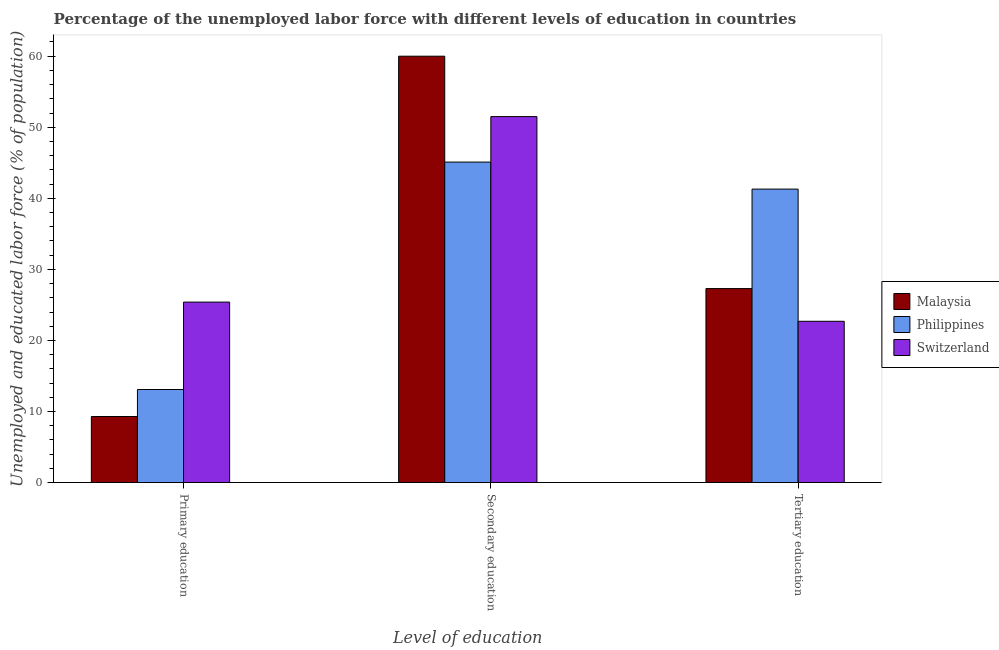How many different coloured bars are there?
Your answer should be very brief. 3. Are the number of bars on each tick of the X-axis equal?
Provide a short and direct response. Yes. How many bars are there on the 2nd tick from the left?
Offer a terse response. 3. What is the label of the 2nd group of bars from the left?
Provide a short and direct response. Secondary education. What is the percentage of labor force who received secondary education in Philippines?
Give a very brief answer. 45.1. Across all countries, what is the minimum percentage of labor force who received secondary education?
Keep it short and to the point. 45.1. In which country was the percentage of labor force who received primary education maximum?
Your response must be concise. Switzerland. In which country was the percentage of labor force who received tertiary education minimum?
Provide a short and direct response. Switzerland. What is the total percentage of labor force who received tertiary education in the graph?
Provide a succinct answer. 91.3. What is the difference between the percentage of labor force who received primary education in Malaysia and that in Switzerland?
Keep it short and to the point. -16.1. What is the difference between the percentage of labor force who received secondary education in Philippines and the percentage of labor force who received primary education in Malaysia?
Provide a short and direct response. 35.8. What is the average percentage of labor force who received tertiary education per country?
Keep it short and to the point. 30.43. What is the difference between the percentage of labor force who received tertiary education and percentage of labor force who received secondary education in Philippines?
Your answer should be compact. -3.8. In how many countries, is the percentage of labor force who received primary education greater than 32 %?
Ensure brevity in your answer.  0. What is the ratio of the percentage of labor force who received tertiary education in Malaysia to that in Switzerland?
Provide a succinct answer. 1.2. Is the difference between the percentage of labor force who received tertiary education in Malaysia and Switzerland greater than the difference between the percentage of labor force who received secondary education in Malaysia and Switzerland?
Give a very brief answer. No. What is the difference between the highest and the lowest percentage of labor force who received secondary education?
Your answer should be very brief. 14.9. In how many countries, is the percentage of labor force who received secondary education greater than the average percentage of labor force who received secondary education taken over all countries?
Provide a short and direct response. 1. Is the sum of the percentage of labor force who received tertiary education in Philippines and Switzerland greater than the maximum percentage of labor force who received primary education across all countries?
Provide a short and direct response. Yes. What does the 1st bar from the right in Primary education represents?
Your response must be concise. Switzerland. Is it the case that in every country, the sum of the percentage of labor force who received primary education and percentage of labor force who received secondary education is greater than the percentage of labor force who received tertiary education?
Ensure brevity in your answer.  Yes. Are all the bars in the graph horizontal?
Ensure brevity in your answer.  No. How many countries are there in the graph?
Your answer should be very brief. 3. What is the difference between two consecutive major ticks on the Y-axis?
Your response must be concise. 10. Does the graph contain any zero values?
Provide a short and direct response. No. Does the graph contain grids?
Your answer should be very brief. No. How many legend labels are there?
Provide a short and direct response. 3. What is the title of the graph?
Make the answer very short. Percentage of the unemployed labor force with different levels of education in countries. Does "Israel" appear as one of the legend labels in the graph?
Provide a short and direct response. No. What is the label or title of the X-axis?
Your answer should be very brief. Level of education. What is the label or title of the Y-axis?
Make the answer very short. Unemployed and educated labor force (% of population). What is the Unemployed and educated labor force (% of population) in Malaysia in Primary education?
Make the answer very short. 9.3. What is the Unemployed and educated labor force (% of population) in Philippines in Primary education?
Keep it short and to the point. 13.1. What is the Unemployed and educated labor force (% of population) of Switzerland in Primary education?
Provide a succinct answer. 25.4. What is the Unemployed and educated labor force (% of population) in Philippines in Secondary education?
Your answer should be compact. 45.1. What is the Unemployed and educated labor force (% of population) of Switzerland in Secondary education?
Make the answer very short. 51.5. What is the Unemployed and educated labor force (% of population) in Malaysia in Tertiary education?
Make the answer very short. 27.3. What is the Unemployed and educated labor force (% of population) in Philippines in Tertiary education?
Give a very brief answer. 41.3. What is the Unemployed and educated labor force (% of population) in Switzerland in Tertiary education?
Ensure brevity in your answer.  22.7. Across all Level of education, what is the maximum Unemployed and educated labor force (% of population) of Malaysia?
Offer a very short reply. 60. Across all Level of education, what is the maximum Unemployed and educated labor force (% of population) in Philippines?
Your answer should be very brief. 45.1. Across all Level of education, what is the maximum Unemployed and educated labor force (% of population) in Switzerland?
Give a very brief answer. 51.5. Across all Level of education, what is the minimum Unemployed and educated labor force (% of population) of Malaysia?
Make the answer very short. 9.3. Across all Level of education, what is the minimum Unemployed and educated labor force (% of population) of Philippines?
Provide a succinct answer. 13.1. Across all Level of education, what is the minimum Unemployed and educated labor force (% of population) in Switzerland?
Offer a very short reply. 22.7. What is the total Unemployed and educated labor force (% of population) of Malaysia in the graph?
Your answer should be very brief. 96.6. What is the total Unemployed and educated labor force (% of population) in Philippines in the graph?
Your answer should be compact. 99.5. What is the total Unemployed and educated labor force (% of population) in Switzerland in the graph?
Keep it short and to the point. 99.6. What is the difference between the Unemployed and educated labor force (% of population) in Malaysia in Primary education and that in Secondary education?
Provide a succinct answer. -50.7. What is the difference between the Unemployed and educated labor force (% of population) in Philippines in Primary education and that in Secondary education?
Your response must be concise. -32. What is the difference between the Unemployed and educated labor force (% of population) in Switzerland in Primary education and that in Secondary education?
Offer a very short reply. -26.1. What is the difference between the Unemployed and educated labor force (% of population) in Philippines in Primary education and that in Tertiary education?
Provide a short and direct response. -28.2. What is the difference between the Unemployed and educated labor force (% of population) of Switzerland in Primary education and that in Tertiary education?
Your answer should be very brief. 2.7. What is the difference between the Unemployed and educated labor force (% of population) in Malaysia in Secondary education and that in Tertiary education?
Keep it short and to the point. 32.7. What is the difference between the Unemployed and educated labor force (% of population) of Switzerland in Secondary education and that in Tertiary education?
Your response must be concise. 28.8. What is the difference between the Unemployed and educated labor force (% of population) in Malaysia in Primary education and the Unemployed and educated labor force (% of population) in Philippines in Secondary education?
Your answer should be compact. -35.8. What is the difference between the Unemployed and educated labor force (% of population) of Malaysia in Primary education and the Unemployed and educated labor force (% of population) of Switzerland in Secondary education?
Your response must be concise. -42.2. What is the difference between the Unemployed and educated labor force (% of population) in Philippines in Primary education and the Unemployed and educated labor force (% of population) in Switzerland in Secondary education?
Your answer should be compact. -38.4. What is the difference between the Unemployed and educated labor force (% of population) of Malaysia in Primary education and the Unemployed and educated labor force (% of population) of Philippines in Tertiary education?
Make the answer very short. -32. What is the difference between the Unemployed and educated labor force (% of population) of Malaysia in Primary education and the Unemployed and educated labor force (% of population) of Switzerland in Tertiary education?
Keep it short and to the point. -13.4. What is the difference between the Unemployed and educated labor force (% of population) in Malaysia in Secondary education and the Unemployed and educated labor force (% of population) in Switzerland in Tertiary education?
Give a very brief answer. 37.3. What is the difference between the Unemployed and educated labor force (% of population) in Philippines in Secondary education and the Unemployed and educated labor force (% of population) in Switzerland in Tertiary education?
Your answer should be very brief. 22.4. What is the average Unemployed and educated labor force (% of population) in Malaysia per Level of education?
Your answer should be very brief. 32.2. What is the average Unemployed and educated labor force (% of population) of Philippines per Level of education?
Keep it short and to the point. 33.17. What is the average Unemployed and educated labor force (% of population) of Switzerland per Level of education?
Give a very brief answer. 33.2. What is the difference between the Unemployed and educated labor force (% of population) in Malaysia and Unemployed and educated labor force (% of population) in Switzerland in Primary education?
Your response must be concise. -16.1. What is the difference between the Unemployed and educated labor force (% of population) of Malaysia and Unemployed and educated labor force (% of population) of Philippines in Secondary education?
Provide a succinct answer. 14.9. What is the difference between the Unemployed and educated labor force (% of population) of Malaysia and Unemployed and educated labor force (% of population) of Switzerland in Secondary education?
Your answer should be compact. 8.5. What is the difference between the Unemployed and educated labor force (% of population) of Philippines and Unemployed and educated labor force (% of population) of Switzerland in Secondary education?
Keep it short and to the point. -6.4. What is the difference between the Unemployed and educated labor force (% of population) in Malaysia and Unemployed and educated labor force (% of population) in Switzerland in Tertiary education?
Provide a succinct answer. 4.6. What is the ratio of the Unemployed and educated labor force (% of population) in Malaysia in Primary education to that in Secondary education?
Offer a very short reply. 0.15. What is the ratio of the Unemployed and educated labor force (% of population) in Philippines in Primary education to that in Secondary education?
Your answer should be very brief. 0.29. What is the ratio of the Unemployed and educated labor force (% of population) in Switzerland in Primary education to that in Secondary education?
Your answer should be compact. 0.49. What is the ratio of the Unemployed and educated labor force (% of population) in Malaysia in Primary education to that in Tertiary education?
Give a very brief answer. 0.34. What is the ratio of the Unemployed and educated labor force (% of population) in Philippines in Primary education to that in Tertiary education?
Your answer should be very brief. 0.32. What is the ratio of the Unemployed and educated labor force (% of population) of Switzerland in Primary education to that in Tertiary education?
Offer a very short reply. 1.12. What is the ratio of the Unemployed and educated labor force (% of population) of Malaysia in Secondary education to that in Tertiary education?
Your answer should be very brief. 2.2. What is the ratio of the Unemployed and educated labor force (% of population) in Philippines in Secondary education to that in Tertiary education?
Make the answer very short. 1.09. What is the ratio of the Unemployed and educated labor force (% of population) of Switzerland in Secondary education to that in Tertiary education?
Offer a terse response. 2.27. What is the difference between the highest and the second highest Unemployed and educated labor force (% of population) of Malaysia?
Offer a terse response. 32.7. What is the difference between the highest and the second highest Unemployed and educated labor force (% of population) in Philippines?
Make the answer very short. 3.8. What is the difference between the highest and the second highest Unemployed and educated labor force (% of population) in Switzerland?
Offer a terse response. 26.1. What is the difference between the highest and the lowest Unemployed and educated labor force (% of population) of Malaysia?
Your answer should be compact. 50.7. What is the difference between the highest and the lowest Unemployed and educated labor force (% of population) in Philippines?
Make the answer very short. 32. What is the difference between the highest and the lowest Unemployed and educated labor force (% of population) of Switzerland?
Your answer should be very brief. 28.8. 